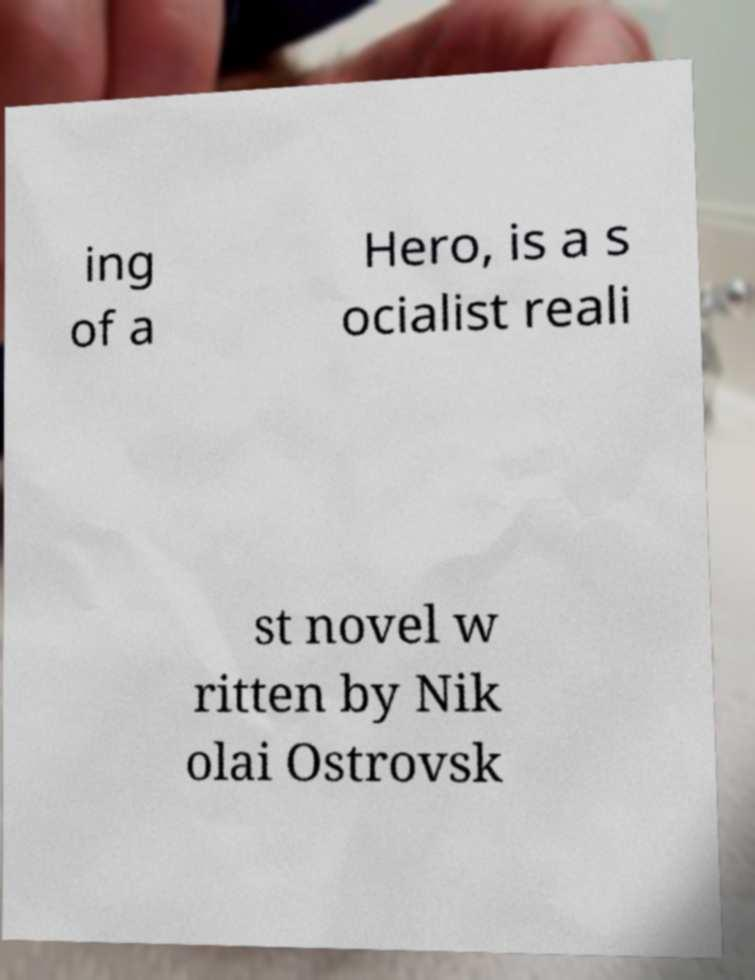What messages or text are displayed in this image? I need them in a readable, typed format. ing of a Hero, is a s ocialist reali st novel w ritten by Nik olai Ostrovsk 